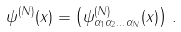Convert formula to latex. <formula><loc_0><loc_0><loc_500><loc_500>\psi ^ { ( N ) } ( x ) = \left ( \psi ^ { ( N ) } _ { \alpha _ { 1 } \alpha _ { 2 } \dots \alpha _ { N } } ( x ) \right ) \, .</formula> 